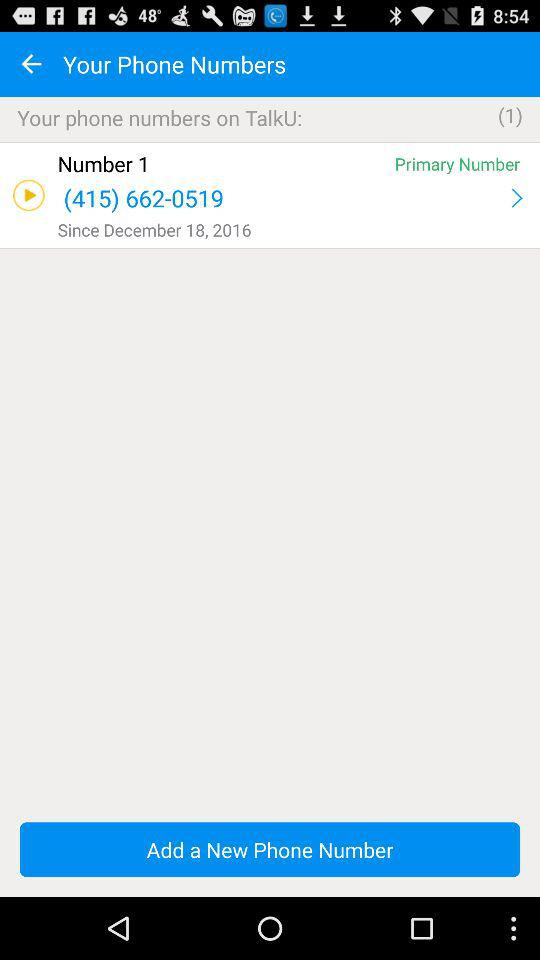What is the phone number of "Number 1"? The phone number is (415) 662-0519. 